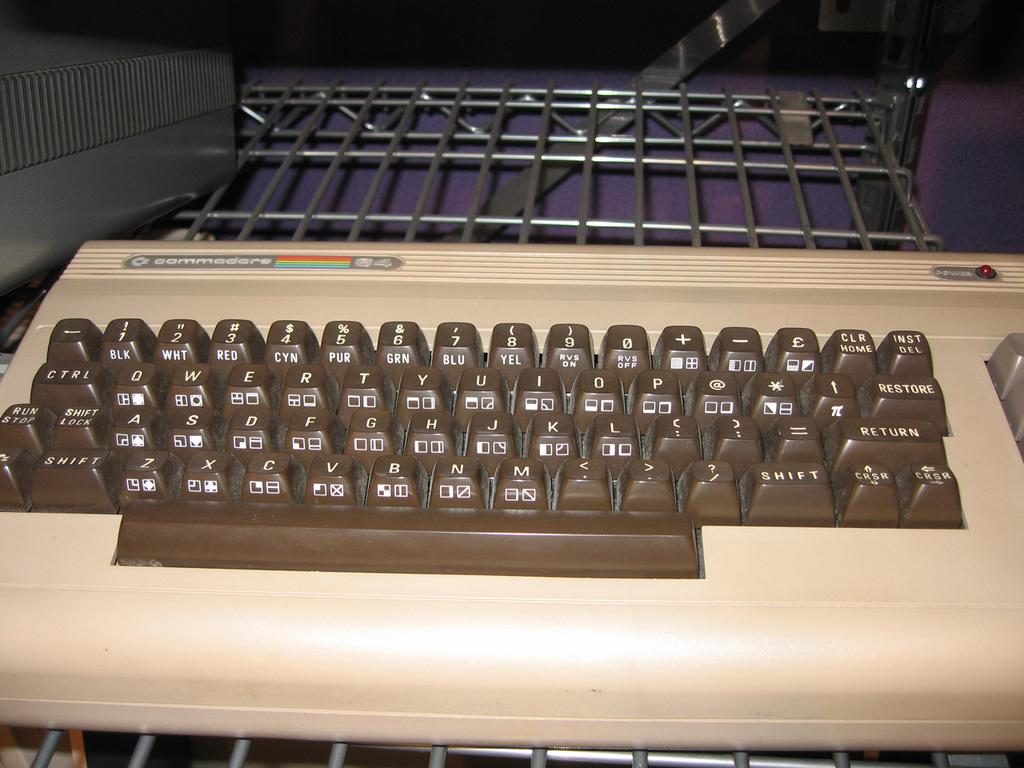<image>
Offer a succinct explanation of the picture presented. An old brown and beige keyboard from the Commodore 64. 